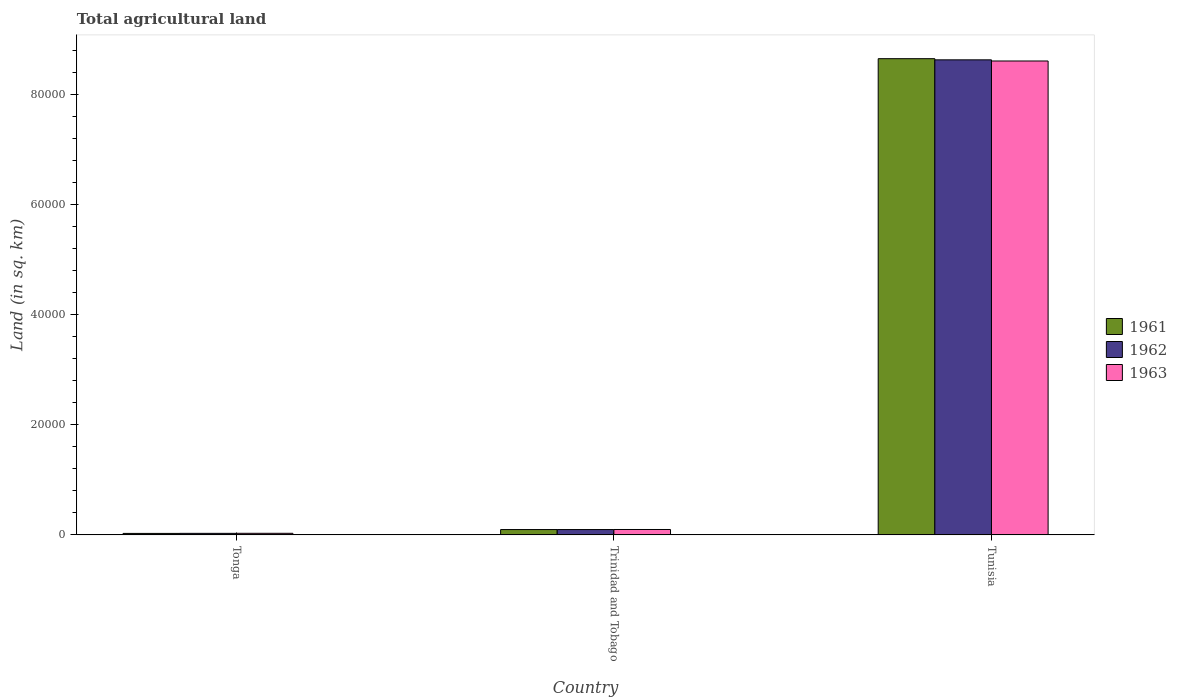Are the number of bars per tick equal to the number of legend labels?
Offer a terse response. Yes. How many bars are there on the 2nd tick from the left?
Your response must be concise. 3. How many bars are there on the 1st tick from the right?
Your response must be concise. 3. What is the label of the 3rd group of bars from the left?
Offer a very short reply. Tunisia. In how many cases, is the number of bars for a given country not equal to the number of legend labels?
Offer a terse response. 0. What is the total agricultural land in 1963 in Tonga?
Make the answer very short. 290. Across all countries, what is the maximum total agricultural land in 1962?
Make the answer very short. 8.63e+04. Across all countries, what is the minimum total agricultural land in 1962?
Offer a very short reply. 280. In which country was the total agricultural land in 1961 maximum?
Ensure brevity in your answer.  Tunisia. In which country was the total agricultural land in 1961 minimum?
Offer a terse response. Tonga. What is the total total agricultural land in 1961 in the graph?
Your response must be concise. 8.77e+04. What is the difference between the total agricultural land in 1962 in Tonga and that in Tunisia?
Keep it short and to the point. -8.60e+04. What is the difference between the total agricultural land in 1963 in Trinidad and Tobago and the total agricultural land in 1961 in Tunisia?
Ensure brevity in your answer.  -8.55e+04. What is the average total agricultural land in 1962 per country?
Your response must be concise. 2.92e+04. What is the difference between the total agricultural land of/in 1963 and total agricultural land of/in 1961 in Tonga?
Make the answer very short. 20. In how many countries, is the total agricultural land in 1961 greater than 60000 sq.km?
Keep it short and to the point. 1. What is the ratio of the total agricultural land in 1963 in Tonga to that in Trinidad and Tobago?
Make the answer very short. 0.3. What is the difference between the highest and the second highest total agricultural land in 1962?
Your response must be concise. -690. What is the difference between the highest and the lowest total agricultural land in 1962?
Your response must be concise. 8.60e+04. Is the sum of the total agricultural land in 1963 in Tonga and Tunisia greater than the maximum total agricultural land in 1962 across all countries?
Offer a terse response. Yes. How many countries are there in the graph?
Your answer should be very brief. 3. What is the difference between two consecutive major ticks on the Y-axis?
Make the answer very short. 2.00e+04. How are the legend labels stacked?
Your answer should be very brief. Vertical. What is the title of the graph?
Your response must be concise. Total agricultural land. Does "1986" appear as one of the legend labels in the graph?
Keep it short and to the point. No. What is the label or title of the X-axis?
Make the answer very short. Country. What is the label or title of the Y-axis?
Make the answer very short. Land (in sq. km). What is the Land (in sq. km) in 1961 in Tonga?
Offer a very short reply. 270. What is the Land (in sq. km) in 1962 in Tonga?
Your response must be concise. 280. What is the Land (in sq. km) in 1963 in Tonga?
Offer a terse response. 290. What is the Land (in sq. km) in 1961 in Trinidad and Tobago?
Offer a very short reply. 970. What is the Land (in sq. km) in 1962 in Trinidad and Tobago?
Make the answer very short. 970. What is the Land (in sq. km) in 1963 in Trinidad and Tobago?
Give a very brief answer. 980. What is the Land (in sq. km) in 1961 in Tunisia?
Ensure brevity in your answer.  8.65e+04. What is the Land (in sq. km) of 1962 in Tunisia?
Ensure brevity in your answer.  8.63e+04. What is the Land (in sq. km) in 1963 in Tunisia?
Offer a very short reply. 8.61e+04. Across all countries, what is the maximum Land (in sq. km) of 1961?
Ensure brevity in your answer.  8.65e+04. Across all countries, what is the maximum Land (in sq. km) in 1962?
Your answer should be compact. 8.63e+04. Across all countries, what is the maximum Land (in sq. km) of 1963?
Offer a terse response. 8.61e+04. Across all countries, what is the minimum Land (in sq. km) in 1961?
Provide a short and direct response. 270. Across all countries, what is the minimum Land (in sq. km) in 1962?
Offer a very short reply. 280. Across all countries, what is the minimum Land (in sq. km) in 1963?
Your answer should be compact. 290. What is the total Land (in sq. km) of 1961 in the graph?
Ensure brevity in your answer.  8.77e+04. What is the total Land (in sq. km) of 1962 in the graph?
Offer a very short reply. 8.75e+04. What is the total Land (in sq. km) of 1963 in the graph?
Provide a succinct answer. 8.73e+04. What is the difference between the Land (in sq. km) in 1961 in Tonga and that in Trinidad and Tobago?
Keep it short and to the point. -700. What is the difference between the Land (in sq. km) in 1962 in Tonga and that in Trinidad and Tobago?
Your response must be concise. -690. What is the difference between the Land (in sq. km) in 1963 in Tonga and that in Trinidad and Tobago?
Provide a succinct answer. -690. What is the difference between the Land (in sq. km) in 1961 in Tonga and that in Tunisia?
Offer a terse response. -8.62e+04. What is the difference between the Land (in sq. km) of 1962 in Tonga and that in Tunisia?
Your response must be concise. -8.60e+04. What is the difference between the Land (in sq. km) of 1963 in Tonga and that in Tunisia?
Provide a succinct answer. -8.58e+04. What is the difference between the Land (in sq. km) in 1961 in Trinidad and Tobago and that in Tunisia?
Provide a short and direct response. -8.55e+04. What is the difference between the Land (in sq. km) of 1962 in Trinidad and Tobago and that in Tunisia?
Your answer should be compact. -8.53e+04. What is the difference between the Land (in sq. km) of 1963 in Trinidad and Tobago and that in Tunisia?
Your answer should be compact. -8.51e+04. What is the difference between the Land (in sq. km) of 1961 in Tonga and the Land (in sq. km) of 1962 in Trinidad and Tobago?
Ensure brevity in your answer.  -700. What is the difference between the Land (in sq. km) of 1961 in Tonga and the Land (in sq. km) of 1963 in Trinidad and Tobago?
Keep it short and to the point. -710. What is the difference between the Land (in sq. km) of 1962 in Tonga and the Land (in sq. km) of 1963 in Trinidad and Tobago?
Your response must be concise. -700. What is the difference between the Land (in sq. km) of 1961 in Tonga and the Land (in sq. km) of 1962 in Tunisia?
Offer a terse response. -8.60e+04. What is the difference between the Land (in sq. km) in 1961 in Tonga and the Land (in sq. km) in 1963 in Tunisia?
Offer a terse response. -8.58e+04. What is the difference between the Land (in sq. km) of 1962 in Tonga and the Land (in sq. km) of 1963 in Tunisia?
Offer a very short reply. -8.58e+04. What is the difference between the Land (in sq. km) of 1961 in Trinidad and Tobago and the Land (in sq. km) of 1962 in Tunisia?
Your answer should be compact. -8.53e+04. What is the difference between the Land (in sq. km) of 1961 in Trinidad and Tobago and the Land (in sq. km) of 1963 in Tunisia?
Offer a terse response. -8.51e+04. What is the difference between the Land (in sq. km) in 1962 in Trinidad and Tobago and the Land (in sq. km) in 1963 in Tunisia?
Your answer should be very brief. -8.51e+04. What is the average Land (in sq. km) of 1961 per country?
Provide a succinct answer. 2.92e+04. What is the average Land (in sq. km) of 1962 per country?
Your response must be concise. 2.92e+04. What is the average Land (in sq. km) in 1963 per country?
Ensure brevity in your answer.  2.91e+04. What is the difference between the Land (in sq. km) in 1961 and Land (in sq. km) in 1962 in Tonga?
Offer a terse response. -10. What is the difference between the Land (in sq. km) in 1961 and Land (in sq. km) in 1963 in Tonga?
Provide a succinct answer. -20. What is the difference between the Land (in sq. km) of 1961 and Land (in sq. km) of 1962 in Trinidad and Tobago?
Your answer should be compact. 0. What is the difference between the Land (in sq. km) of 1961 and Land (in sq. km) of 1963 in Trinidad and Tobago?
Your response must be concise. -10. What is the difference between the Land (in sq. km) in 1961 and Land (in sq. km) in 1962 in Tunisia?
Your response must be concise. 210. What is the difference between the Land (in sq. km) in 1961 and Land (in sq. km) in 1963 in Tunisia?
Your response must be concise. 420. What is the difference between the Land (in sq. km) of 1962 and Land (in sq. km) of 1963 in Tunisia?
Your response must be concise. 210. What is the ratio of the Land (in sq. km) in 1961 in Tonga to that in Trinidad and Tobago?
Give a very brief answer. 0.28. What is the ratio of the Land (in sq. km) of 1962 in Tonga to that in Trinidad and Tobago?
Provide a succinct answer. 0.29. What is the ratio of the Land (in sq. km) in 1963 in Tonga to that in Trinidad and Tobago?
Offer a terse response. 0.3. What is the ratio of the Land (in sq. km) in 1961 in Tonga to that in Tunisia?
Ensure brevity in your answer.  0. What is the ratio of the Land (in sq. km) of 1962 in Tonga to that in Tunisia?
Provide a succinct answer. 0. What is the ratio of the Land (in sq. km) of 1963 in Tonga to that in Tunisia?
Your answer should be very brief. 0. What is the ratio of the Land (in sq. km) in 1961 in Trinidad and Tobago to that in Tunisia?
Your answer should be very brief. 0.01. What is the ratio of the Land (in sq. km) in 1962 in Trinidad and Tobago to that in Tunisia?
Your answer should be compact. 0.01. What is the ratio of the Land (in sq. km) of 1963 in Trinidad and Tobago to that in Tunisia?
Offer a very short reply. 0.01. What is the difference between the highest and the second highest Land (in sq. km) in 1961?
Ensure brevity in your answer.  8.55e+04. What is the difference between the highest and the second highest Land (in sq. km) in 1962?
Offer a very short reply. 8.53e+04. What is the difference between the highest and the second highest Land (in sq. km) of 1963?
Give a very brief answer. 8.51e+04. What is the difference between the highest and the lowest Land (in sq. km) of 1961?
Keep it short and to the point. 8.62e+04. What is the difference between the highest and the lowest Land (in sq. km) in 1962?
Offer a very short reply. 8.60e+04. What is the difference between the highest and the lowest Land (in sq. km) in 1963?
Provide a short and direct response. 8.58e+04. 